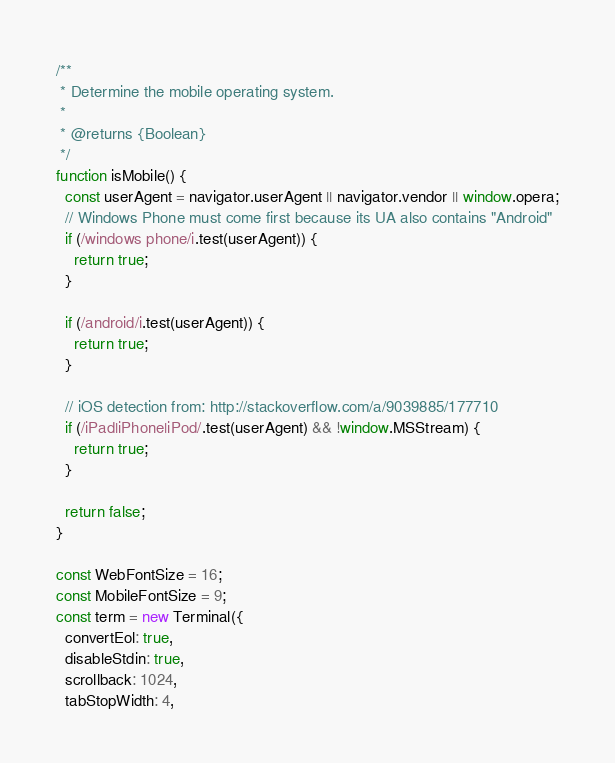Convert code to text. <code><loc_0><loc_0><loc_500><loc_500><_JavaScript_>/**
 * Determine the mobile operating system.
 *
 * @returns {Boolean}
 */
function isMobile() {
  const userAgent = navigator.userAgent || navigator.vendor || window.opera;
  // Windows Phone must come first because its UA also contains "Android"
  if (/windows phone/i.test(userAgent)) {
    return true;
  }

  if (/android/i.test(userAgent)) {
    return true;
  }

  // iOS detection from: http://stackoverflow.com/a/9039885/177710
  if (/iPad|iPhone|iPod/.test(userAgent) && !window.MSStream) {
    return true;
  }

  return false;
}

const WebFontSize = 16;
const MobileFontSize = 9;
const term = new Terminal({
  convertEol: true,
  disableStdin: true,
  scrollback: 1024,
  tabStopWidth: 4,</code> 